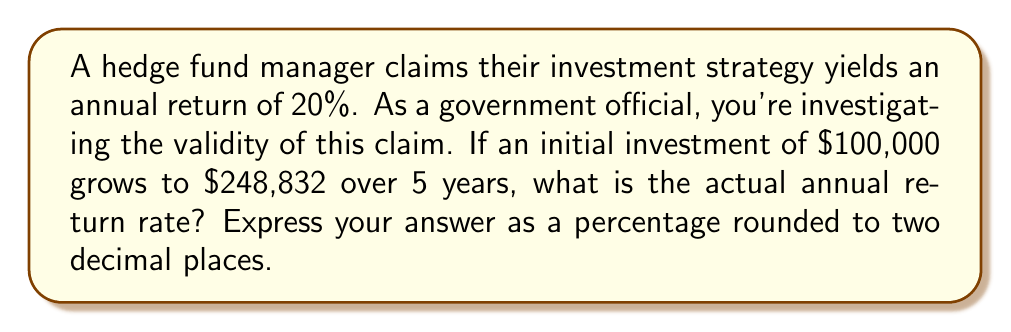Solve this math problem. Let's approach this step-by-step using logarithmic functions:

1) The general formula for compound interest is:
   $A = P(1+r)^t$
   Where A is the final amount, P is the principal (initial investment), r is the annual return rate, and t is the time in years.

2) We know:
   $P = 100,000$
   $A = 248,832$
   $t = 5$

3) Substituting these values into the formula:
   $248,832 = 100,000(1+r)^5$

4) Dividing both sides by 100,000:
   $2.48832 = (1+r)^5$

5) To isolate r, we need to take the logarithm of both sides. Let's use the natural logarithm:
   $\ln(2.48832) = \ln((1+r)^5)$

6) Using the logarithm property $\ln(x^n) = n\ln(x)$:
   $\ln(2.48832) = 5\ln(1+r)$

7) Dividing both sides by 5:
   $\frac{\ln(2.48832)}{5} = \ln(1+r)$

8) Now we can apply the exponential function to both sides:
   $e^{\frac{\ln(2.48832)}{5}} = e^{\ln(1+r)} = 1+r$

9) Subtracting 1 from both sides:
   $e^{\frac{\ln(2.48832)}{5}} - 1 = r$

10) Calculating this:
    $r \approx 0.1998 = 19.98\%$

This is the actual annual return rate, which is slightly lower than the claimed 20%.
Answer: 19.98% 